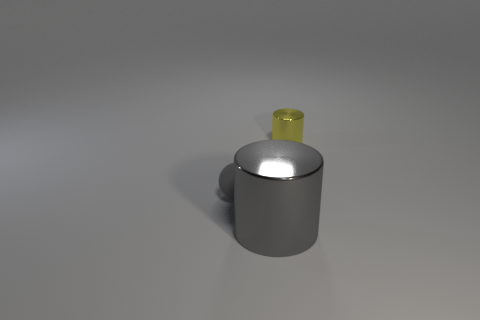Is there anything else that is the same size as the gray metallic cylinder?
Provide a short and direct response. No. Is there anything else that is the same material as the tiny gray ball?
Offer a very short reply. No. Does the yellow cylinder have the same size as the gray matte object?
Your answer should be very brief. Yes. There is a thing that is both on the left side of the tiny yellow shiny cylinder and behind the large gray cylinder; what is its shape?
Keep it short and to the point. Sphere. What number of tiny cyan objects are made of the same material as the big cylinder?
Offer a very short reply. 0. There is a shiny cylinder that is to the left of the yellow object; how many small things are in front of it?
Offer a very short reply. 0. The metallic object in front of the cylinder that is on the right side of the gray shiny object that is on the left side of the tiny shiny cylinder is what shape?
Provide a succinct answer. Cylinder. The object that is the same color as the tiny sphere is what size?
Provide a short and direct response. Large. What number of things are either big blue balls or gray rubber spheres?
Offer a very short reply. 1. What color is the other rubber object that is the same size as the yellow object?
Provide a succinct answer. Gray. 